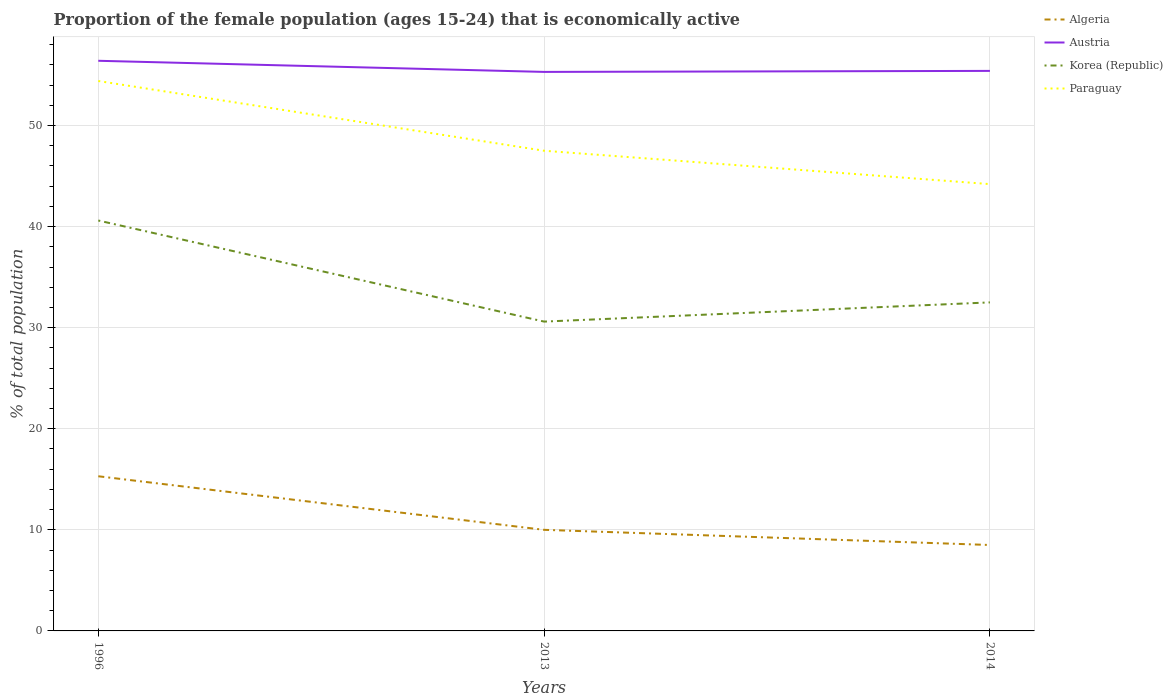How many different coloured lines are there?
Provide a succinct answer. 4. Across all years, what is the maximum proportion of the female population that is economically active in Korea (Republic)?
Offer a terse response. 30.6. In which year was the proportion of the female population that is economically active in Korea (Republic) maximum?
Offer a terse response. 2013. What is the difference between the highest and the second highest proportion of the female population that is economically active in Paraguay?
Keep it short and to the point. 10.2. How many years are there in the graph?
Make the answer very short. 3. Does the graph contain grids?
Provide a succinct answer. Yes. Where does the legend appear in the graph?
Give a very brief answer. Top right. What is the title of the graph?
Give a very brief answer. Proportion of the female population (ages 15-24) that is economically active. What is the label or title of the Y-axis?
Keep it short and to the point. % of total population. What is the % of total population of Algeria in 1996?
Your response must be concise. 15.3. What is the % of total population in Austria in 1996?
Your answer should be very brief. 56.4. What is the % of total population in Korea (Republic) in 1996?
Your response must be concise. 40.6. What is the % of total population in Paraguay in 1996?
Your answer should be compact. 54.4. What is the % of total population of Austria in 2013?
Make the answer very short. 55.3. What is the % of total population in Korea (Republic) in 2013?
Ensure brevity in your answer.  30.6. What is the % of total population in Paraguay in 2013?
Your response must be concise. 47.5. What is the % of total population in Algeria in 2014?
Make the answer very short. 8.5. What is the % of total population in Austria in 2014?
Make the answer very short. 55.4. What is the % of total population of Korea (Republic) in 2014?
Keep it short and to the point. 32.5. What is the % of total population of Paraguay in 2014?
Keep it short and to the point. 44.2. Across all years, what is the maximum % of total population in Algeria?
Ensure brevity in your answer.  15.3. Across all years, what is the maximum % of total population in Austria?
Keep it short and to the point. 56.4. Across all years, what is the maximum % of total population in Korea (Republic)?
Keep it short and to the point. 40.6. Across all years, what is the maximum % of total population of Paraguay?
Offer a very short reply. 54.4. Across all years, what is the minimum % of total population of Algeria?
Offer a very short reply. 8.5. Across all years, what is the minimum % of total population in Austria?
Offer a very short reply. 55.3. Across all years, what is the minimum % of total population of Korea (Republic)?
Your answer should be very brief. 30.6. Across all years, what is the minimum % of total population in Paraguay?
Offer a terse response. 44.2. What is the total % of total population in Algeria in the graph?
Offer a terse response. 33.8. What is the total % of total population of Austria in the graph?
Offer a very short reply. 167.1. What is the total % of total population in Korea (Republic) in the graph?
Keep it short and to the point. 103.7. What is the total % of total population of Paraguay in the graph?
Your response must be concise. 146.1. What is the difference between the % of total population of Algeria in 1996 and that in 2013?
Provide a short and direct response. 5.3. What is the difference between the % of total population in Austria in 1996 and that in 2013?
Provide a succinct answer. 1.1. What is the difference between the % of total population of Paraguay in 1996 and that in 2014?
Your response must be concise. 10.2. What is the difference between the % of total population in Paraguay in 2013 and that in 2014?
Offer a very short reply. 3.3. What is the difference between the % of total population of Algeria in 1996 and the % of total population of Austria in 2013?
Offer a terse response. -40. What is the difference between the % of total population in Algeria in 1996 and the % of total population in Korea (Republic) in 2013?
Ensure brevity in your answer.  -15.3. What is the difference between the % of total population of Algeria in 1996 and the % of total population of Paraguay in 2013?
Provide a short and direct response. -32.2. What is the difference between the % of total population in Austria in 1996 and the % of total population in Korea (Republic) in 2013?
Offer a very short reply. 25.8. What is the difference between the % of total population in Austria in 1996 and the % of total population in Paraguay in 2013?
Make the answer very short. 8.9. What is the difference between the % of total population in Algeria in 1996 and the % of total population in Austria in 2014?
Ensure brevity in your answer.  -40.1. What is the difference between the % of total population of Algeria in 1996 and the % of total population of Korea (Republic) in 2014?
Make the answer very short. -17.2. What is the difference between the % of total population in Algeria in 1996 and the % of total population in Paraguay in 2014?
Keep it short and to the point. -28.9. What is the difference between the % of total population of Austria in 1996 and the % of total population of Korea (Republic) in 2014?
Ensure brevity in your answer.  23.9. What is the difference between the % of total population of Austria in 1996 and the % of total population of Paraguay in 2014?
Offer a very short reply. 12.2. What is the difference between the % of total population in Korea (Republic) in 1996 and the % of total population in Paraguay in 2014?
Offer a very short reply. -3.6. What is the difference between the % of total population in Algeria in 2013 and the % of total population in Austria in 2014?
Your response must be concise. -45.4. What is the difference between the % of total population of Algeria in 2013 and the % of total population of Korea (Republic) in 2014?
Give a very brief answer. -22.5. What is the difference between the % of total population of Algeria in 2013 and the % of total population of Paraguay in 2014?
Your answer should be compact. -34.2. What is the difference between the % of total population of Austria in 2013 and the % of total population of Korea (Republic) in 2014?
Offer a terse response. 22.8. What is the average % of total population in Algeria per year?
Provide a short and direct response. 11.27. What is the average % of total population in Austria per year?
Your response must be concise. 55.7. What is the average % of total population in Korea (Republic) per year?
Keep it short and to the point. 34.57. What is the average % of total population of Paraguay per year?
Give a very brief answer. 48.7. In the year 1996, what is the difference between the % of total population in Algeria and % of total population in Austria?
Provide a short and direct response. -41.1. In the year 1996, what is the difference between the % of total population of Algeria and % of total population of Korea (Republic)?
Offer a very short reply. -25.3. In the year 1996, what is the difference between the % of total population of Algeria and % of total population of Paraguay?
Make the answer very short. -39.1. In the year 1996, what is the difference between the % of total population of Austria and % of total population of Paraguay?
Offer a terse response. 2. In the year 2013, what is the difference between the % of total population of Algeria and % of total population of Austria?
Your answer should be very brief. -45.3. In the year 2013, what is the difference between the % of total population of Algeria and % of total population of Korea (Republic)?
Provide a short and direct response. -20.6. In the year 2013, what is the difference between the % of total population in Algeria and % of total population in Paraguay?
Provide a short and direct response. -37.5. In the year 2013, what is the difference between the % of total population in Austria and % of total population in Korea (Republic)?
Offer a terse response. 24.7. In the year 2013, what is the difference between the % of total population in Korea (Republic) and % of total population in Paraguay?
Provide a short and direct response. -16.9. In the year 2014, what is the difference between the % of total population in Algeria and % of total population in Austria?
Provide a succinct answer. -46.9. In the year 2014, what is the difference between the % of total population in Algeria and % of total population in Paraguay?
Offer a terse response. -35.7. In the year 2014, what is the difference between the % of total population in Austria and % of total population in Korea (Republic)?
Ensure brevity in your answer.  22.9. In the year 2014, what is the difference between the % of total population of Korea (Republic) and % of total population of Paraguay?
Provide a short and direct response. -11.7. What is the ratio of the % of total population in Algeria in 1996 to that in 2013?
Offer a terse response. 1.53. What is the ratio of the % of total population of Austria in 1996 to that in 2013?
Make the answer very short. 1.02. What is the ratio of the % of total population of Korea (Republic) in 1996 to that in 2013?
Make the answer very short. 1.33. What is the ratio of the % of total population of Paraguay in 1996 to that in 2013?
Make the answer very short. 1.15. What is the ratio of the % of total population of Austria in 1996 to that in 2014?
Offer a terse response. 1.02. What is the ratio of the % of total population in Korea (Republic) in 1996 to that in 2014?
Provide a succinct answer. 1.25. What is the ratio of the % of total population of Paraguay in 1996 to that in 2014?
Your response must be concise. 1.23. What is the ratio of the % of total population of Algeria in 2013 to that in 2014?
Provide a short and direct response. 1.18. What is the ratio of the % of total population in Austria in 2013 to that in 2014?
Provide a succinct answer. 1. What is the ratio of the % of total population of Korea (Republic) in 2013 to that in 2014?
Keep it short and to the point. 0.94. What is the ratio of the % of total population of Paraguay in 2013 to that in 2014?
Give a very brief answer. 1.07. What is the difference between the highest and the second highest % of total population of Algeria?
Offer a terse response. 5.3. What is the difference between the highest and the second highest % of total population of Austria?
Make the answer very short. 1. What is the difference between the highest and the second highest % of total population in Korea (Republic)?
Ensure brevity in your answer.  8.1. What is the difference between the highest and the lowest % of total population in Algeria?
Make the answer very short. 6.8. What is the difference between the highest and the lowest % of total population of Korea (Republic)?
Ensure brevity in your answer.  10. What is the difference between the highest and the lowest % of total population of Paraguay?
Your answer should be very brief. 10.2. 